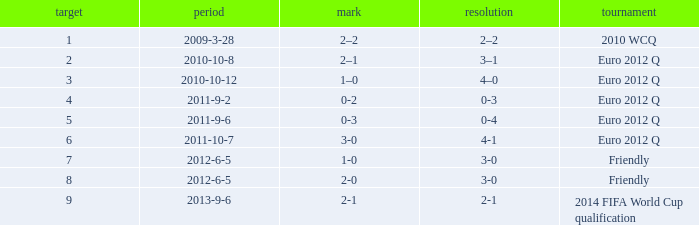I'm looking to parse the entire table for insights. Could you assist me with that? {'header': ['target', 'period', 'mark', 'resolution', 'tournament'], 'rows': [['1', '2009-3-28', '2–2', '2–2', '2010 WCQ'], ['2', '2010-10-8', '2–1', '3–1', 'Euro 2012 Q'], ['3', '2010-10-12', '1–0', '4–0', 'Euro 2012 Q'], ['4', '2011-9-2', '0-2', '0-3', 'Euro 2012 Q'], ['5', '2011-9-6', '0-3', '0-4', 'Euro 2012 Q'], ['6', '2011-10-7', '3-0', '4-1', 'Euro 2012 Q'], ['7', '2012-6-5', '1-0', '3-0', 'Friendly'], ['8', '2012-6-5', '2-0', '3-0', 'Friendly'], ['9', '2013-9-6', '2-1', '2-1', '2014 FIFA World Cup qualification']]} What is the result when the score is 0-2? 0-3. 